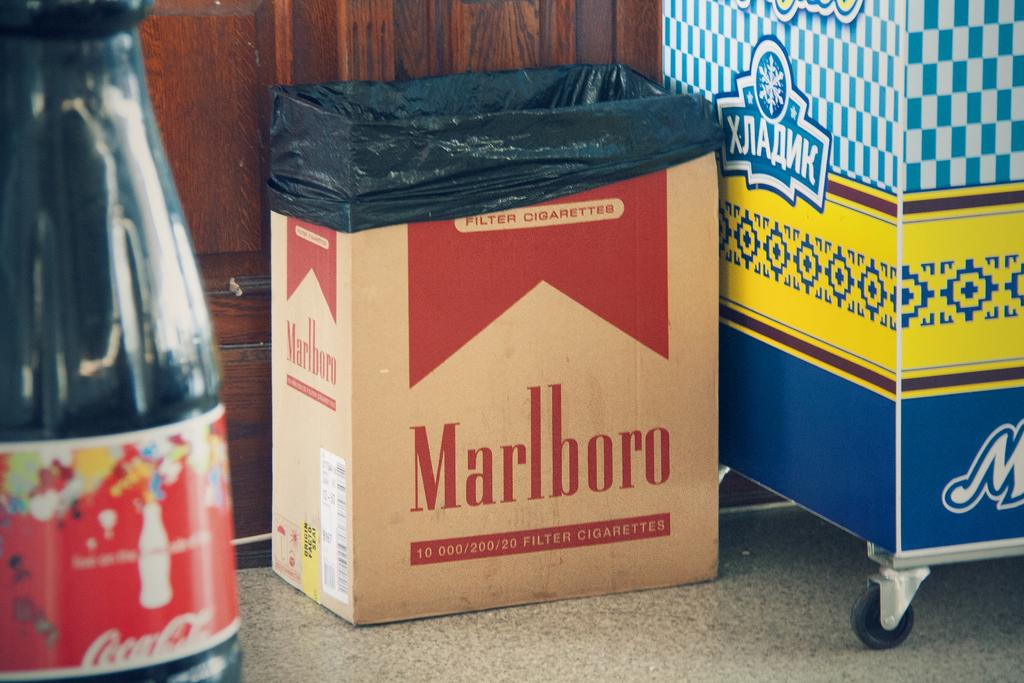<image>
Relay a brief, clear account of the picture shown. A cardboard box labeled with the Marlboro cigarette logo has a black trash bag in it. 